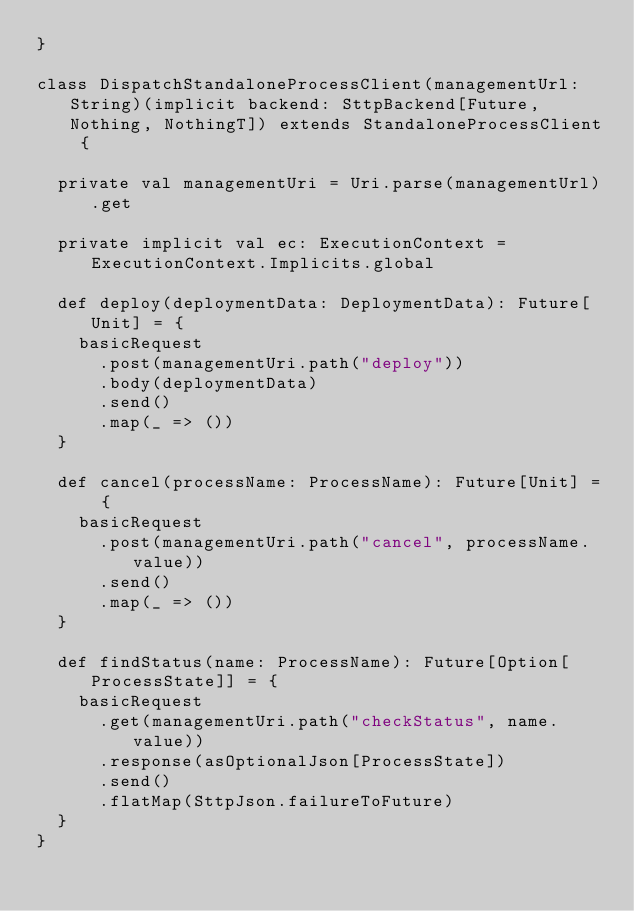<code> <loc_0><loc_0><loc_500><loc_500><_Scala_>}

class DispatchStandaloneProcessClient(managementUrl: String)(implicit backend: SttpBackend[Future, Nothing, NothingT]) extends StandaloneProcessClient {

  private val managementUri = Uri.parse(managementUrl).get

  private implicit val ec: ExecutionContext = ExecutionContext.Implicits.global

  def deploy(deploymentData: DeploymentData): Future[Unit] = {
    basicRequest
      .post(managementUri.path("deploy"))
      .body(deploymentData)
      .send()
      .map(_ => ())
  }

  def cancel(processName: ProcessName): Future[Unit] = {
    basicRequest
      .post(managementUri.path("cancel", processName.value))
      .send()
      .map(_ => ())
  }

  def findStatus(name: ProcessName): Future[Option[ProcessState]] = {
    basicRequest
      .get(managementUri.path("checkStatus", name.value))
      .response(asOptionalJson[ProcessState])
      .send()
      .flatMap(SttpJson.failureToFuture)
  }
}

</code> 